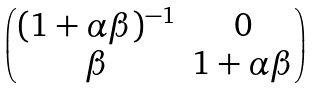<formula> <loc_0><loc_0><loc_500><loc_500>\begin{pmatrix} ( 1 + \alpha \beta ) ^ { - 1 } & 0 \\ \beta & 1 + \alpha \beta \end{pmatrix}</formula> 